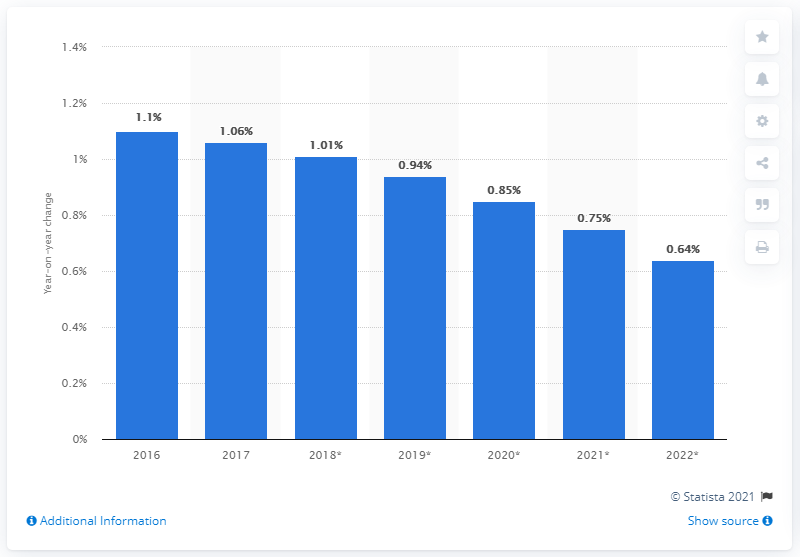Highlight a few significant elements in this photo. In 2017, the number of mobile phone internet users in Japan increased by 1.06 billion. 